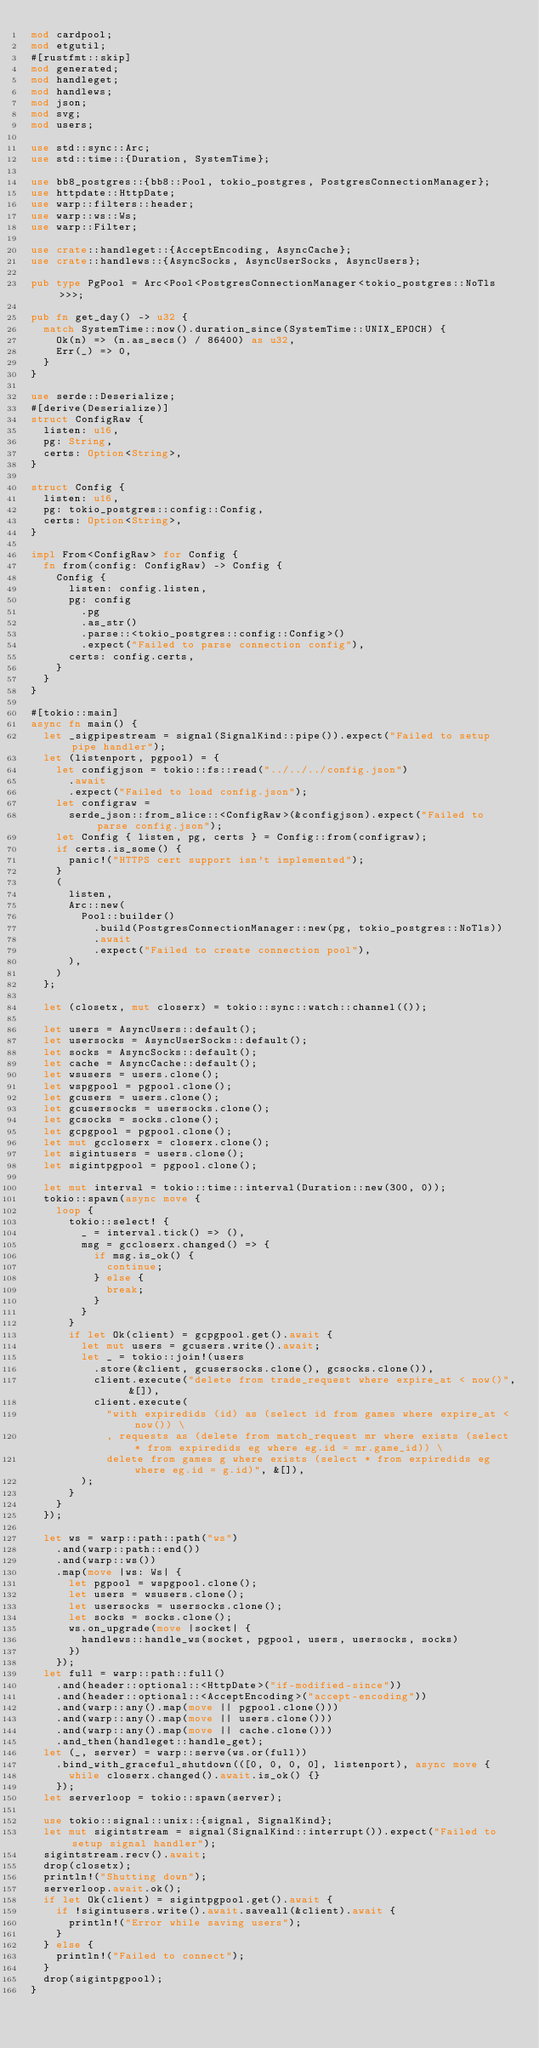<code> <loc_0><loc_0><loc_500><loc_500><_Rust_>mod cardpool;
mod etgutil;
#[rustfmt::skip]
mod generated;
mod handleget;
mod handlews;
mod json;
mod svg;
mod users;

use std::sync::Arc;
use std::time::{Duration, SystemTime};

use bb8_postgres::{bb8::Pool, tokio_postgres, PostgresConnectionManager};
use httpdate::HttpDate;
use warp::filters::header;
use warp::ws::Ws;
use warp::Filter;

use crate::handleget::{AcceptEncoding, AsyncCache};
use crate::handlews::{AsyncSocks, AsyncUserSocks, AsyncUsers};

pub type PgPool = Arc<Pool<PostgresConnectionManager<tokio_postgres::NoTls>>>;

pub fn get_day() -> u32 {
	match SystemTime::now().duration_since(SystemTime::UNIX_EPOCH) {
		Ok(n) => (n.as_secs() / 86400) as u32,
		Err(_) => 0,
	}
}

use serde::Deserialize;
#[derive(Deserialize)]
struct ConfigRaw {
	listen: u16,
	pg: String,
	certs: Option<String>,
}

struct Config {
	listen: u16,
	pg: tokio_postgres::config::Config,
	certs: Option<String>,
}

impl From<ConfigRaw> for Config {
	fn from(config: ConfigRaw) -> Config {
		Config {
			listen: config.listen,
			pg: config
				.pg
				.as_str()
				.parse::<tokio_postgres::config::Config>()
				.expect("Failed to parse connection config"),
			certs: config.certs,
		}
	}
}

#[tokio::main]
async fn main() {
	let _sigpipestream = signal(SignalKind::pipe()).expect("Failed to setup pipe handler");
	let (listenport, pgpool) = {
		let configjson = tokio::fs::read("../../../config.json")
			.await
			.expect("Failed to load config.json");
		let configraw =
			serde_json::from_slice::<ConfigRaw>(&configjson).expect("Failed to parse config.json");
		let Config { listen, pg, certs } = Config::from(configraw);
		if certs.is_some() {
			panic!("HTTPS cert support isn't implemented");
		}
		(
			listen,
			Arc::new(
				Pool::builder()
					.build(PostgresConnectionManager::new(pg, tokio_postgres::NoTls))
					.await
					.expect("Failed to create connection pool"),
			),
		)
	};

	let (closetx, mut closerx) = tokio::sync::watch::channel(());

	let users = AsyncUsers::default();
	let usersocks = AsyncUserSocks::default();
	let socks = AsyncSocks::default();
	let cache = AsyncCache::default();
	let wsusers = users.clone();
	let wspgpool = pgpool.clone();
	let gcusers = users.clone();
	let gcusersocks = usersocks.clone();
	let gcsocks = socks.clone();
	let gcpgpool = pgpool.clone();
	let mut gccloserx = closerx.clone();
	let sigintusers = users.clone();
	let sigintpgpool = pgpool.clone();

	let mut interval = tokio::time::interval(Duration::new(300, 0));
	tokio::spawn(async move {
		loop {
			tokio::select! {
				_ = interval.tick() => (),
				msg = gccloserx.changed() => {
					if msg.is_ok() {
						continue;
					} else {
						break;
					}
				}
			}
			if let Ok(client) = gcpgpool.get().await {
				let mut users = gcusers.write().await;
				let _ = tokio::join!(users
					.store(&client, gcusersocks.clone(), gcsocks.clone()),
					client.execute("delete from trade_request where expire_at < now()", &[]),
					client.execute(
						"with expiredids (id) as (select id from games where expire_at < now()) \
						, requests as (delete from match_request mr where exists (select * from expiredids eg where eg.id = mr.game_id)) \
						delete from games g where exists (select * from expiredids eg where eg.id = g.id)", &[]),
				);
			}
		}
	});

	let ws = warp::path::path("ws")
		.and(warp::path::end())
		.and(warp::ws())
		.map(move |ws: Ws| {
			let pgpool = wspgpool.clone();
			let users = wsusers.clone();
			let usersocks = usersocks.clone();
			let socks = socks.clone();
			ws.on_upgrade(move |socket| {
				handlews::handle_ws(socket, pgpool, users, usersocks, socks)
			})
		});
	let full = warp::path::full()
		.and(header::optional::<HttpDate>("if-modified-since"))
		.and(header::optional::<AcceptEncoding>("accept-encoding"))
		.and(warp::any().map(move || pgpool.clone()))
		.and(warp::any().map(move || users.clone()))
		.and(warp::any().map(move || cache.clone()))
		.and_then(handleget::handle_get);
	let (_, server) = warp::serve(ws.or(full))
		.bind_with_graceful_shutdown(([0, 0, 0, 0], listenport), async move {
			while closerx.changed().await.is_ok() {}
		});
	let serverloop = tokio::spawn(server);

	use tokio::signal::unix::{signal, SignalKind};
	let mut sigintstream = signal(SignalKind::interrupt()).expect("Failed to setup signal handler");
	sigintstream.recv().await;
	drop(closetx);
	println!("Shutting down");
	serverloop.await.ok();
	if let Ok(client) = sigintpgpool.get().await {
		if !sigintusers.write().await.saveall(&client).await {
			println!("Error while saving users");
		}
	} else {
		println!("Failed to connect");
	}
	drop(sigintpgpool);
}
</code> 